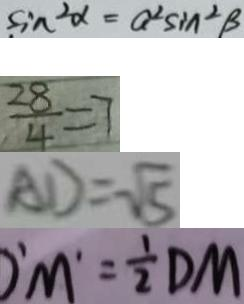Convert formula to latex. <formula><loc_0><loc_0><loc_500><loc_500>\sin ^ { 2 } \alpha = a ^ { 2 } \sin ^ { 2 } B 
 \frac { 2 8 } { 4 } = 7 
 A D = \sqrt { 5 } 
 O ^ { \prime } M ^ { \prime } = \frac { 1 } { 2 } D M</formula> 